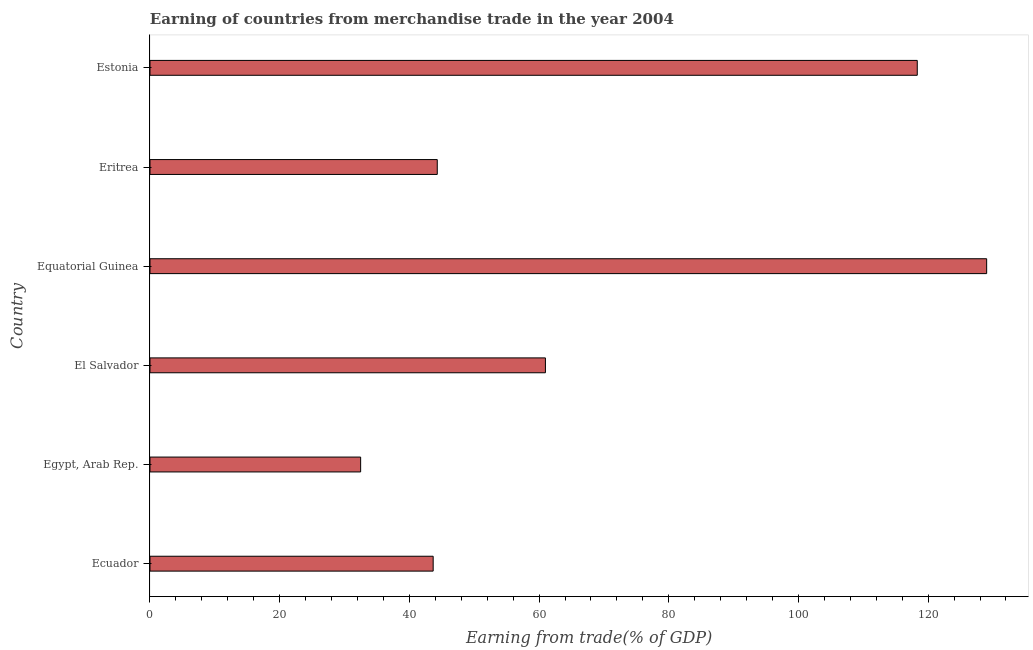Does the graph contain grids?
Give a very brief answer. No. What is the title of the graph?
Your answer should be compact. Earning of countries from merchandise trade in the year 2004. What is the label or title of the X-axis?
Provide a short and direct response. Earning from trade(% of GDP). What is the earning from merchandise trade in Egypt, Arab Rep.?
Make the answer very short. 32.48. Across all countries, what is the maximum earning from merchandise trade?
Your response must be concise. 129.02. Across all countries, what is the minimum earning from merchandise trade?
Your answer should be very brief. 32.48. In which country was the earning from merchandise trade maximum?
Provide a succinct answer. Equatorial Guinea. In which country was the earning from merchandise trade minimum?
Your answer should be very brief. Egypt, Arab Rep. What is the sum of the earning from merchandise trade?
Your response must be concise. 428.77. What is the difference between the earning from merchandise trade in Equatorial Guinea and Eritrea?
Your answer should be compact. 84.72. What is the average earning from merchandise trade per country?
Ensure brevity in your answer.  71.46. What is the median earning from merchandise trade?
Offer a very short reply. 52.64. What is the ratio of the earning from merchandise trade in El Salvador to that in Eritrea?
Give a very brief answer. 1.38. What is the difference between the highest and the second highest earning from merchandise trade?
Give a very brief answer. 10.7. What is the difference between the highest and the lowest earning from merchandise trade?
Provide a succinct answer. 96.54. How many bars are there?
Give a very brief answer. 6. What is the difference between two consecutive major ticks on the X-axis?
Your response must be concise. 20. What is the Earning from trade(% of GDP) in Ecuador?
Ensure brevity in your answer.  43.67. What is the Earning from trade(% of GDP) in Egypt, Arab Rep.?
Provide a succinct answer. 32.48. What is the Earning from trade(% of GDP) in El Salvador?
Offer a very short reply. 60.98. What is the Earning from trade(% of GDP) in Equatorial Guinea?
Ensure brevity in your answer.  129.02. What is the Earning from trade(% of GDP) of Eritrea?
Ensure brevity in your answer.  44.3. What is the Earning from trade(% of GDP) of Estonia?
Provide a succinct answer. 118.32. What is the difference between the Earning from trade(% of GDP) in Ecuador and Egypt, Arab Rep.?
Your answer should be compact. 11.19. What is the difference between the Earning from trade(% of GDP) in Ecuador and El Salvador?
Provide a short and direct response. -17.31. What is the difference between the Earning from trade(% of GDP) in Ecuador and Equatorial Guinea?
Your response must be concise. -85.35. What is the difference between the Earning from trade(% of GDP) in Ecuador and Eritrea?
Provide a short and direct response. -0.63. What is the difference between the Earning from trade(% of GDP) in Ecuador and Estonia?
Keep it short and to the point. -74.65. What is the difference between the Earning from trade(% of GDP) in Egypt, Arab Rep. and El Salvador?
Provide a succinct answer. -28.5. What is the difference between the Earning from trade(% of GDP) in Egypt, Arab Rep. and Equatorial Guinea?
Provide a succinct answer. -96.54. What is the difference between the Earning from trade(% of GDP) in Egypt, Arab Rep. and Eritrea?
Offer a very short reply. -11.82. What is the difference between the Earning from trade(% of GDP) in Egypt, Arab Rep. and Estonia?
Give a very brief answer. -85.84. What is the difference between the Earning from trade(% of GDP) in El Salvador and Equatorial Guinea?
Your response must be concise. -68.04. What is the difference between the Earning from trade(% of GDP) in El Salvador and Eritrea?
Provide a succinct answer. 16.68. What is the difference between the Earning from trade(% of GDP) in El Salvador and Estonia?
Ensure brevity in your answer.  -57.34. What is the difference between the Earning from trade(% of GDP) in Equatorial Guinea and Eritrea?
Provide a succinct answer. 84.72. What is the difference between the Earning from trade(% of GDP) in Equatorial Guinea and Estonia?
Make the answer very short. 10.7. What is the difference between the Earning from trade(% of GDP) in Eritrea and Estonia?
Provide a short and direct response. -74.02. What is the ratio of the Earning from trade(% of GDP) in Ecuador to that in Egypt, Arab Rep.?
Provide a succinct answer. 1.34. What is the ratio of the Earning from trade(% of GDP) in Ecuador to that in El Salvador?
Ensure brevity in your answer.  0.72. What is the ratio of the Earning from trade(% of GDP) in Ecuador to that in Equatorial Guinea?
Provide a short and direct response. 0.34. What is the ratio of the Earning from trade(% of GDP) in Ecuador to that in Estonia?
Make the answer very short. 0.37. What is the ratio of the Earning from trade(% of GDP) in Egypt, Arab Rep. to that in El Salvador?
Provide a short and direct response. 0.53. What is the ratio of the Earning from trade(% of GDP) in Egypt, Arab Rep. to that in Equatorial Guinea?
Keep it short and to the point. 0.25. What is the ratio of the Earning from trade(% of GDP) in Egypt, Arab Rep. to that in Eritrea?
Provide a short and direct response. 0.73. What is the ratio of the Earning from trade(% of GDP) in Egypt, Arab Rep. to that in Estonia?
Offer a terse response. 0.28. What is the ratio of the Earning from trade(% of GDP) in El Salvador to that in Equatorial Guinea?
Give a very brief answer. 0.47. What is the ratio of the Earning from trade(% of GDP) in El Salvador to that in Eritrea?
Offer a terse response. 1.38. What is the ratio of the Earning from trade(% of GDP) in El Salvador to that in Estonia?
Provide a succinct answer. 0.52. What is the ratio of the Earning from trade(% of GDP) in Equatorial Guinea to that in Eritrea?
Give a very brief answer. 2.91. What is the ratio of the Earning from trade(% of GDP) in Equatorial Guinea to that in Estonia?
Make the answer very short. 1.09. What is the ratio of the Earning from trade(% of GDP) in Eritrea to that in Estonia?
Your answer should be very brief. 0.37. 